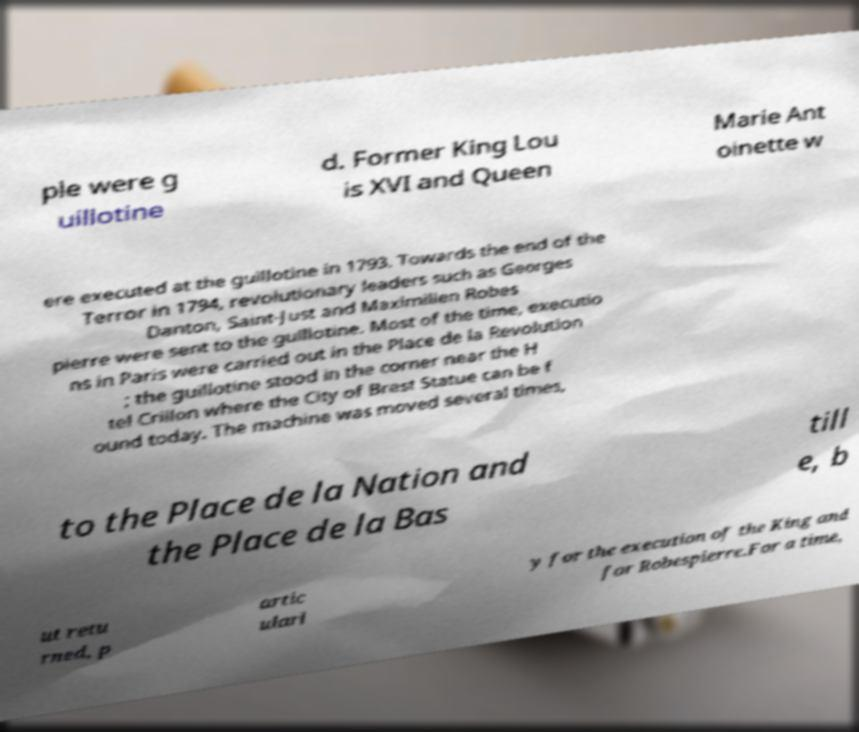What messages or text are displayed in this image? I need them in a readable, typed format. ple were g uillotine d. Former King Lou is XVI and Queen Marie Ant oinette w ere executed at the guillotine in 1793. Towards the end of the Terror in 1794, revolutionary leaders such as Georges Danton, Saint-Just and Maximilien Robes pierre were sent to the guillotine. Most of the time, executio ns in Paris were carried out in the Place de la Revolution ; the guillotine stood in the corner near the H tel Crillon where the City of Brest Statue can be f ound today. The machine was moved several times, to the Place de la Nation and the Place de la Bas till e, b ut retu rned, p artic ularl y for the execution of the King and for Robespierre.For a time, 